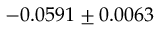Convert formula to latex. <formula><loc_0><loc_0><loc_500><loc_500>- 0 . 0 5 9 1 \pm 0 . 0 0 6 3</formula> 